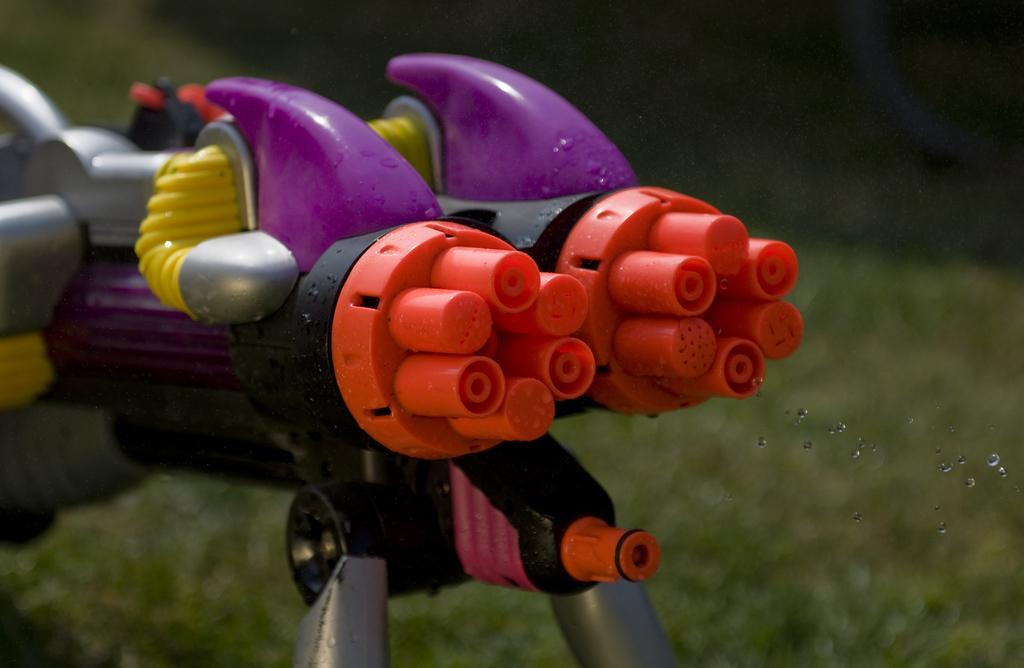What type of toy is present in the picture? There is a toy gun in the picture. What colors can be seen on the toy gun? The toy gun has orange, yellow, violet, and gray colors. On what surface is the toy gun placed? The toy gun is placed on a grass surface. What type of toothbrush is featured in the caption of the image? There is no toothbrush or caption present in the image. 